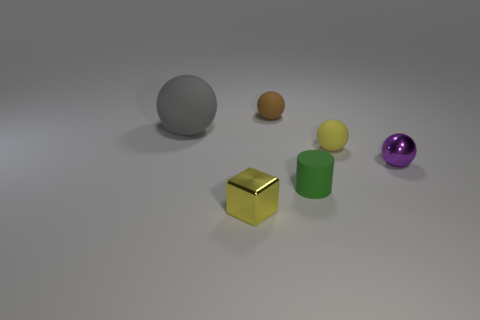Subtract 1 spheres. How many spheres are left? 3 Subtract all red balls. Subtract all green cylinders. How many balls are left? 4 Add 3 brown spheres. How many objects exist? 9 Subtract all blocks. How many objects are left? 5 Add 3 small brown rubber spheres. How many small brown rubber spheres are left? 4 Add 1 small green rubber cylinders. How many small green rubber cylinders exist? 2 Subtract 0 brown cubes. How many objects are left? 6 Subtract all small blue shiny cylinders. Subtract all tiny yellow objects. How many objects are left? 4 